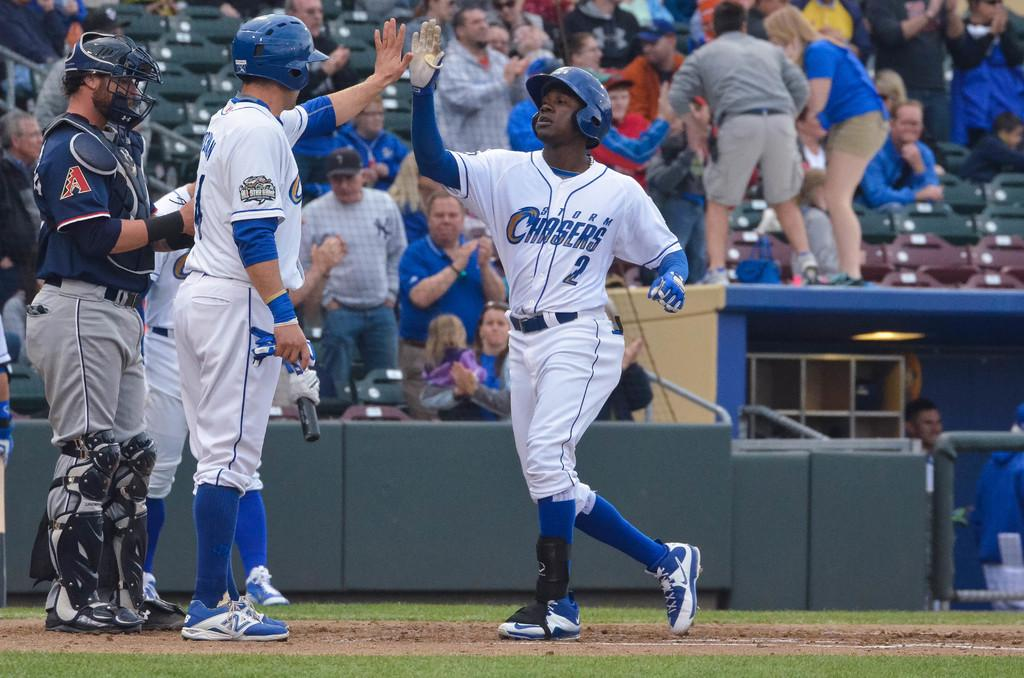<image>
Give a short and clear explanation of the subsequent image. a baseball player that is wearing a Chasers jersey 